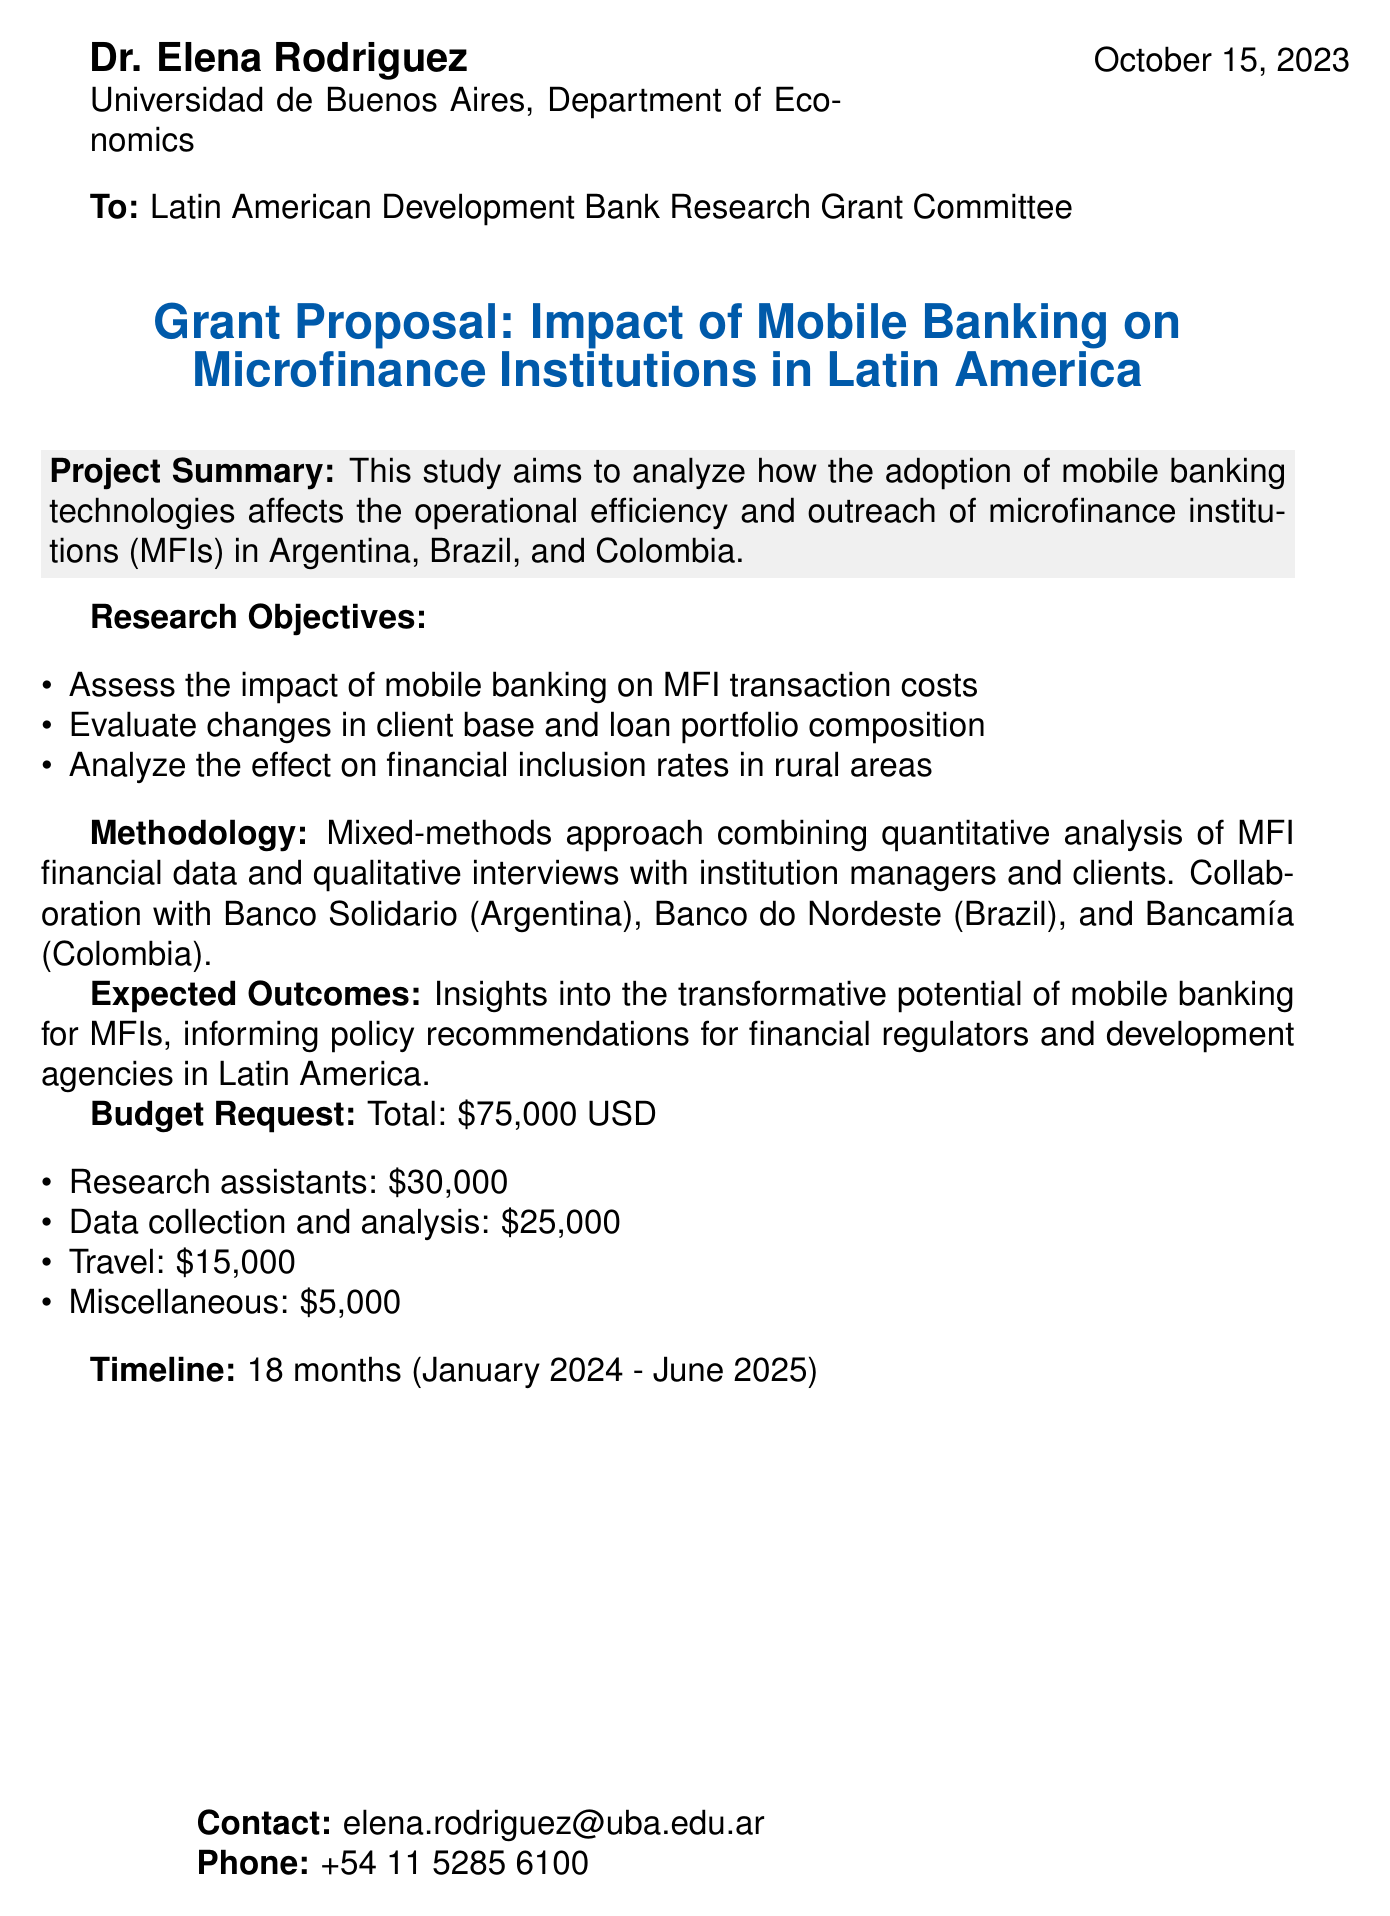What is the grant amount requested? The grant proposal outlines a budget request of $75,000 USD for the study.
Answer: $75,000 USD What are the three countries analyzed in this study? The research focuses on the impact of mobile banking in Argentina, Brazil, and Colombia.
Answer: Argentina, Brazil, Colombia What is the expected timeline for the project? The timeline for the project is set for 18 months, from January 2024 to June 2025.
Answer: 18 months What will the research assistants be paid? The proposal includes a monetary allocation of $30,000 for research assistants.
Answer: $30,000 What is the main goal of the study? The primary goal is to analyze the effect of mobile banking technologies on microfinance institutions' efficiency and outreach.
Answer: Analyze the effect of mobile banking technologies What is the name of the contact person for this proposal? The contact person listed for the proposal is Dr. Elena Rodriguez.
Answer: Dr. Elena Rodriguez What type of approach will be used in the methodology? The study will employ a mixed-methods approach, incorporating both quantitative and qualitative analyses.
Answer: Mixed-methods approach Which institution is collaborating for data collection in Argentina? Banco Solidario is the collaborating institution for data collection in Argentina.
Answer: Banco Solidario 